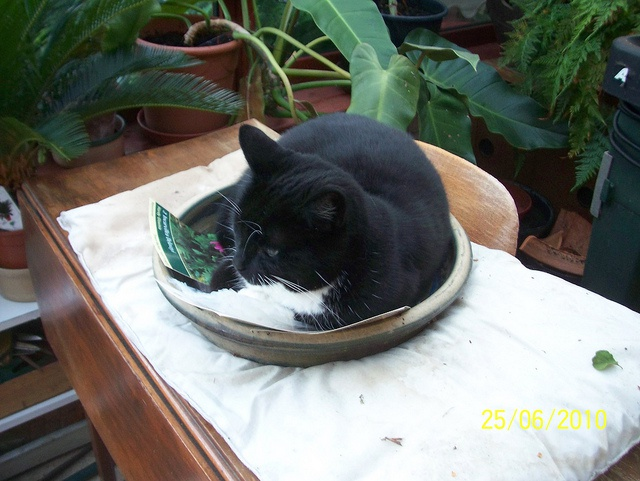Describe the objects in this image and their specific colors. I can see cat in darkgreen, black, gray, and white tones, potted plant in teal, black, darkgreen, and gray tones, potted plant in darkgreen, black, and teal tones, potted plant in darkgreen and black tones, and potted plant in darkgreen, black, maroon, and gray tones in this image. 